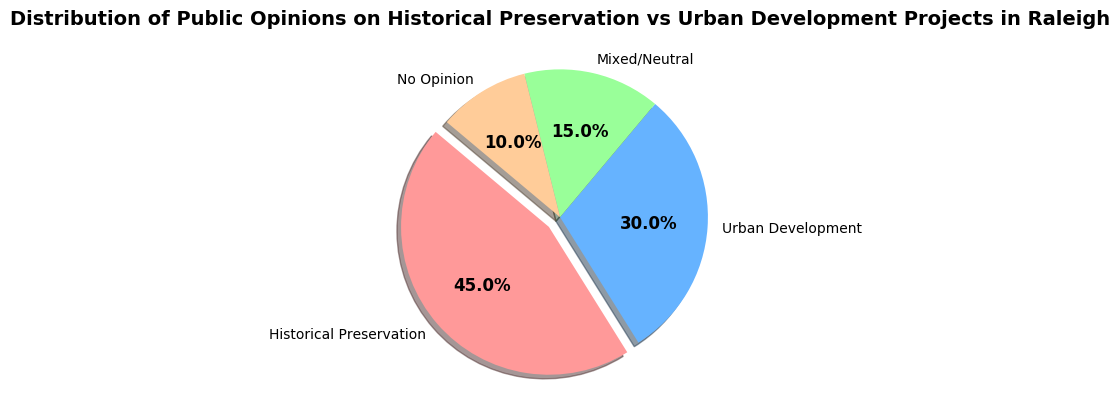What category represents the largest percentage of public opinion? By looking at the pie chart, we can see that the largest section is labeled "Historical Preservation," which is also highlighted by an explode design.
Answer: Historical Preservation Which two categories combined make up more than half of the public opinion? The two largest sections are "Historical Preservation" (45%) and "Urban Development" (30%). Adding these together: 45% + 30% = 75%, which is more than half.
Answer: Historical Preservation and Urban Development How does the percentage of people with no opinion compare to those who are neutral or mixed? The percentage for "No Opinion" is 10%, while "Mixed/Neutral" is 15%. A comparison shows that 10% is less than 15%.
Answer: No Opinion is less than Mixed/Neutral What is the difference in percentage points between the highest and the lowest opinion categories? The highest category is "Historical Preservation" at 45%, and the lowest is "No Opinion" at 10%. The difference is calculated as 45% - 10% = 35 percentage points.
Answer: 35 percentage points Which opinion category has the second-largest share, and what is its percentage? The pie chart shows that the second-largest section after "Historical Preservation" (45%) is "Urban Development" with 30%.
Answer: Urban Development, 30% What is the combined percentage of people who either have no opinion or are mixed/neutral? The "No Opinion" group makes up 10%, and the "Mixed/Neutral" group makes up 15%. Summing these gives 10% + 15% = 25%.
Answer: 25% Which color represents the "Mixed/Neutral" opinion category? Visually, the "Mixed/Neutral" section of the pie chart is shown in a green tone.
Answer: Green How much more support does historical preservation have compared to urban development? "Historical Preservation" has 45% support, while "Urban Development" has 30%. The difference is calculated as 45% - 30% = 15%.
Answer: 15% If you combine all opinions except the "Historical Preservation," what percentage would that be? The percentages for "Urban Development," "Mixed/Neutral," and "No Opinion" are 30%, 15%, and 10% respectively. Summing these: 30% + 15% + 10% = 55%.
Answer: 55% 